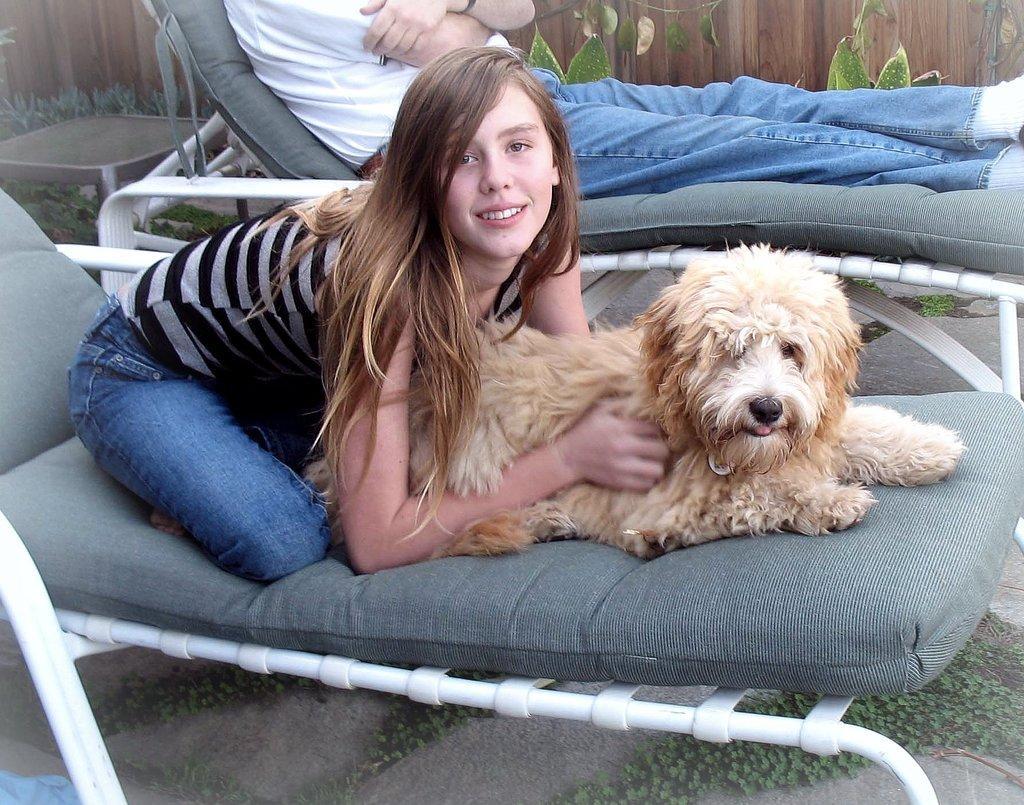Please provide a concise description of this image. In them middle, a woman is sitting on the bed and holding a dog which is sitting in front of her. On the top middle, a person is sitting on the bed. Next to that some plants are visible. And wall of wood visible. At the bottom grass is visible. This image is taken outside the house in a lawn area. 